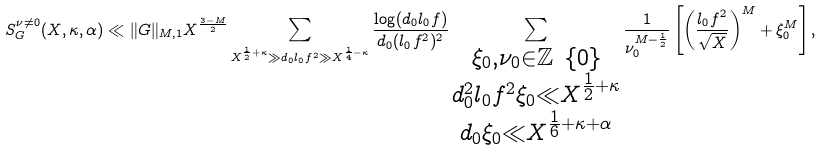<formula> <loc_0><loc_0><loc_500><loc_500>S _ { G } ^ { \nu \neq 0 } ( X , \kappa , \alpha ) \ll \| G \| _ { M , 1 } X ^ { \frac { 3 - M } { 2 } } \sum _ { X ^ { \frac { 1 } { 2 } + \kappa } \gg d _ { 0 } l _ { 0 } f ^ { 2 } \gg X ^ { \frac { 1 } { 4 } - \kappa } } \frac { \log ( d _ { 0 } l _ { 0 } f ) } { d _ { 0 } ( l _ { 0 } f ^ { 2 } ) ^ { 2 } } \sum _ { \substack { \xi _ { 0 } , \nu _ { 0 } \in \mathbb { Z } \ \{ 0 \} \\ d _ { 0 } ^ { 2 } l _ { 0 } f ^ { 2 } \xi _ { 0 } \ll X ^ { \frac { 1 } { 2 } + \kappa } \\ d _ { 0 } \xi _ { 0 } \ll X ^ { \frac { 1 } { 6 } + \kappa + \alpha } } } \frac { 1 } { \nu _ { 0 } ^ { M - \frac { 1 } { 2 } } } \left [ \left ( \frac { l _ { 0 } f ^ { 2 } } { \sqrt { X } } \right ) ^ { M } + \xi _ { 0 } ^ { M } \right ] ,</formula> 